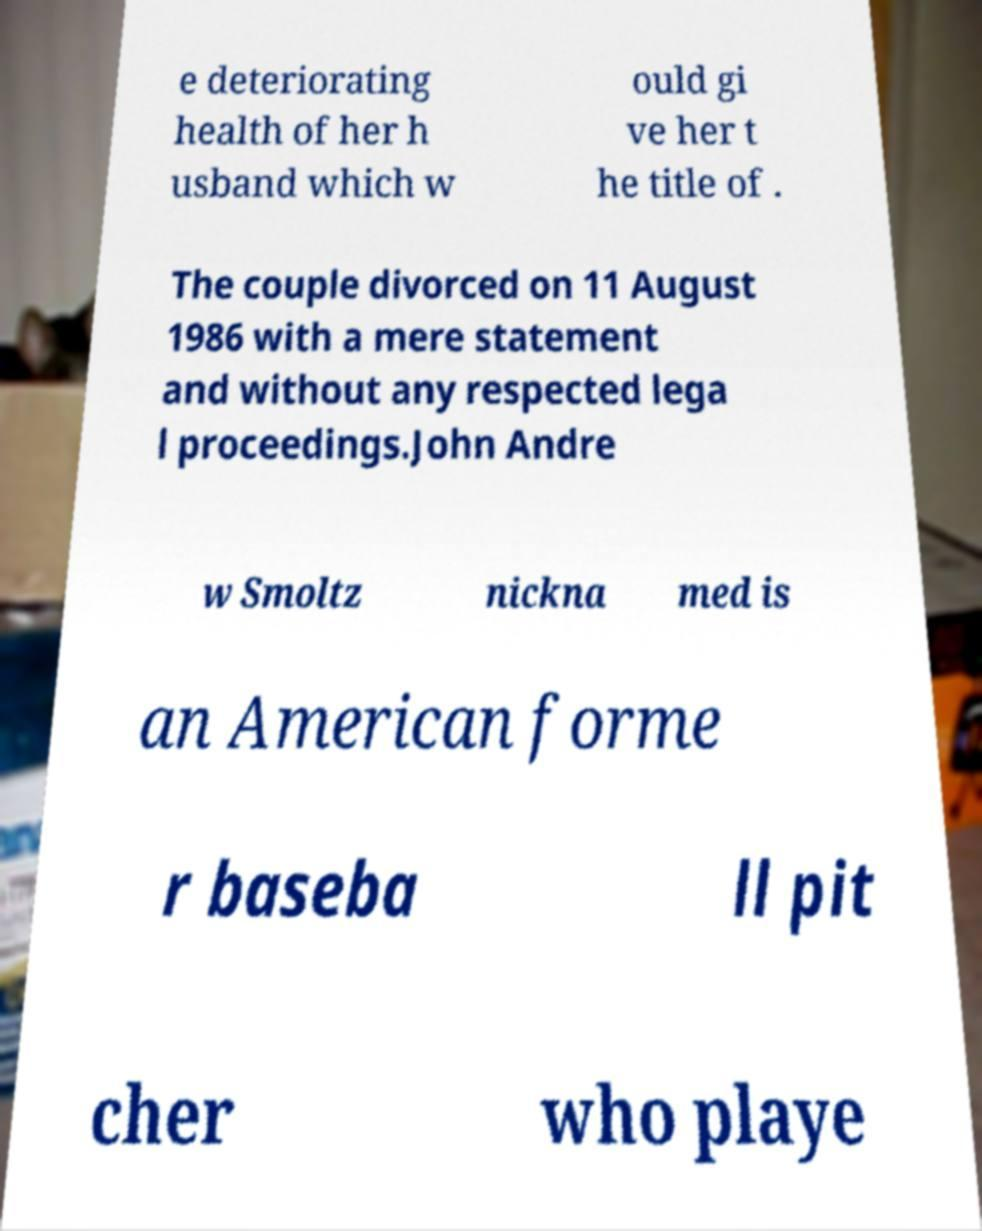Can you read and provide the text displayed in the image?This photo seems to have some interesting text. Can you extract and type it out for me? e deteriorating health of her h usband which w ould gi ve her t he title of . The couple divorced on 11 August 1986 with a mere statement and without any respected lega l proceedings.John Andre w Smoltz nickna med is an American forme r baseba ll pit cher who playe 